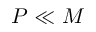<formula> <loc_0><loc_0><loc_500><loc_500>P \ll M</formula> 